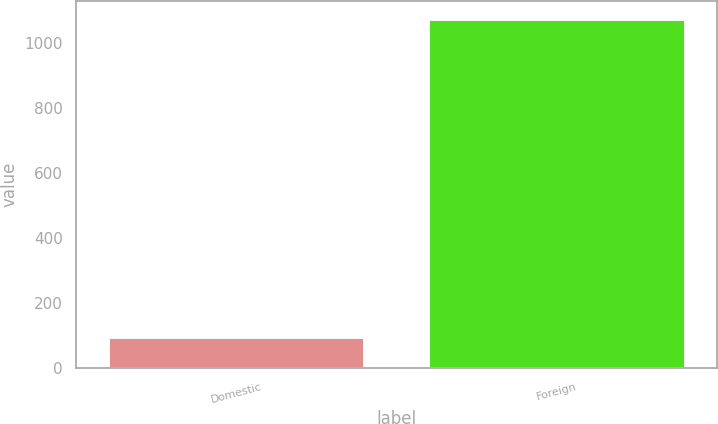<chart> <loc_0><loc_0><loc_500><loc_500><bar_chart><fcel>Domestic<fcel>Foreign<nl><fcel>94.8<fcel>1074<nl></chart> 